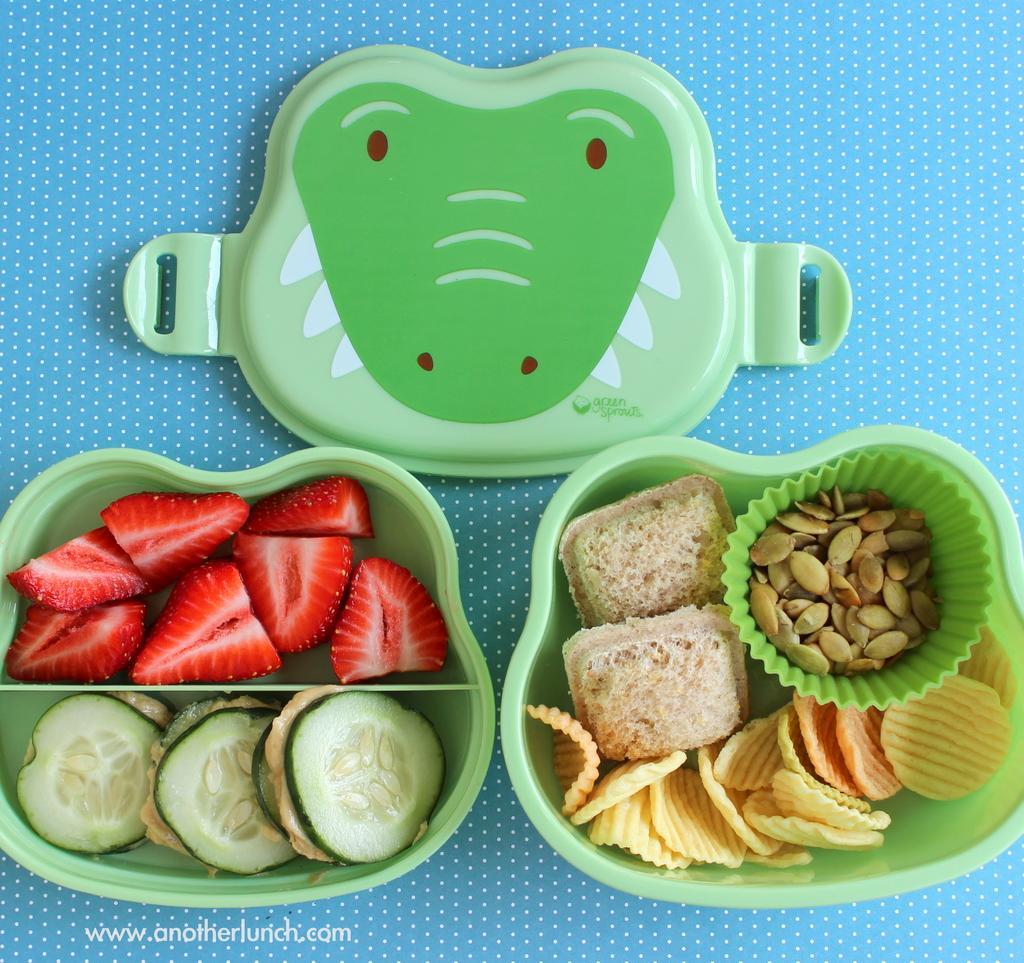In one or two sentences, can you explain what this image depicts? In the left side these are the strawberry pieces in a green color box, in the right side these are the food items in the box. 